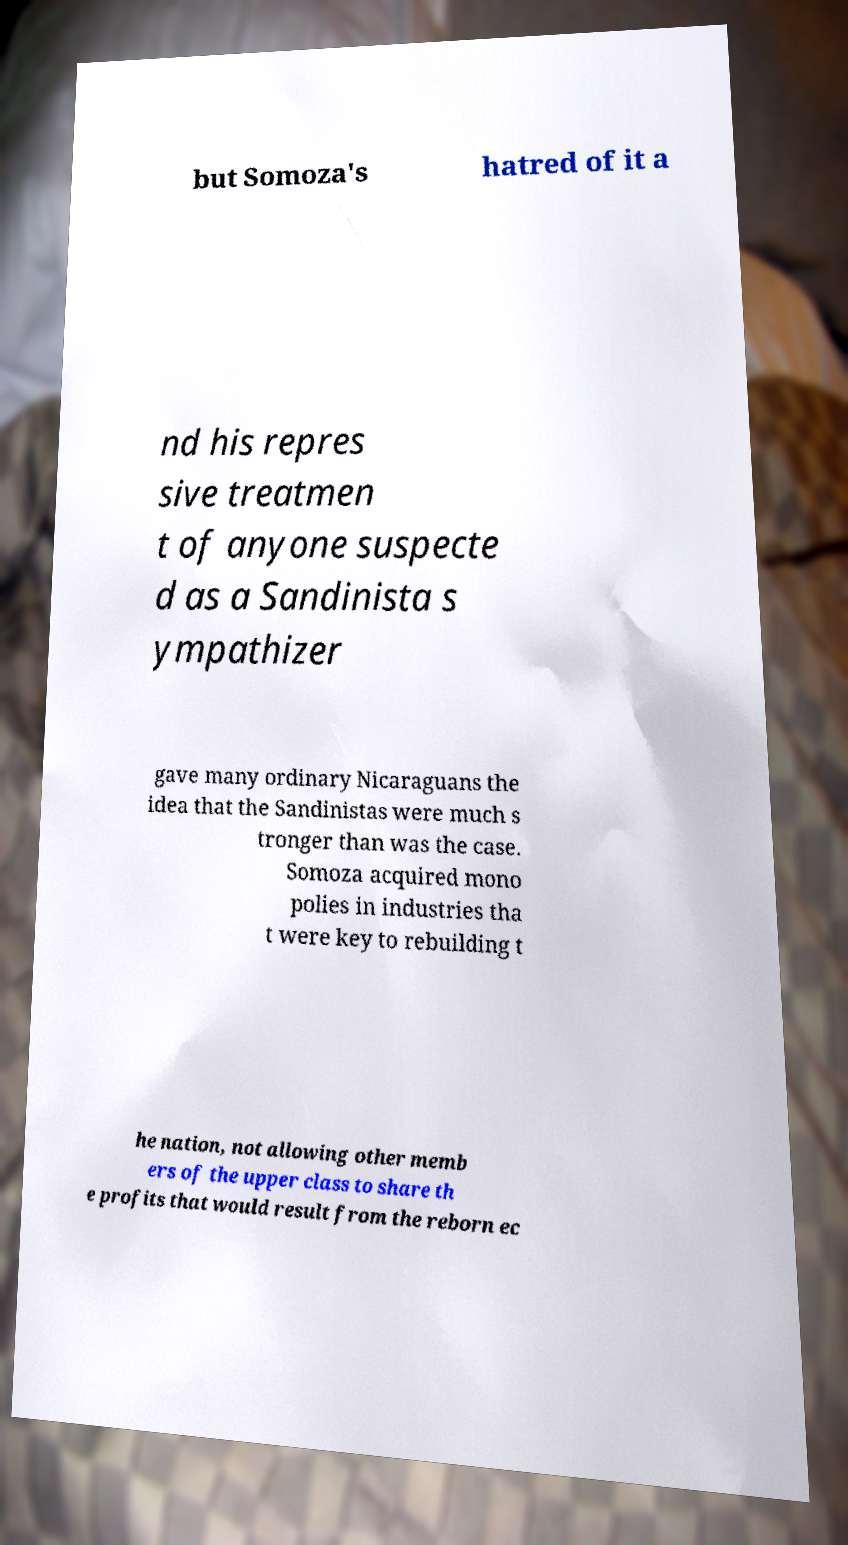There's text embedded in this image that I need extracted. Can you transcribe it verbatim? but Somoza's hatred of it a nd his repres sive treatmen t of anyone suspecte d as a Sandinista s ympathizer gave many ordinary Nicaraguans the idea that the Sandinistas were much s tronger than was the case. Somoza acquired mono polies in industries tha t were key to rebuilding t he nation, not allowing other memb ers of the upper class to share th e profits that would result from the reborn ec 